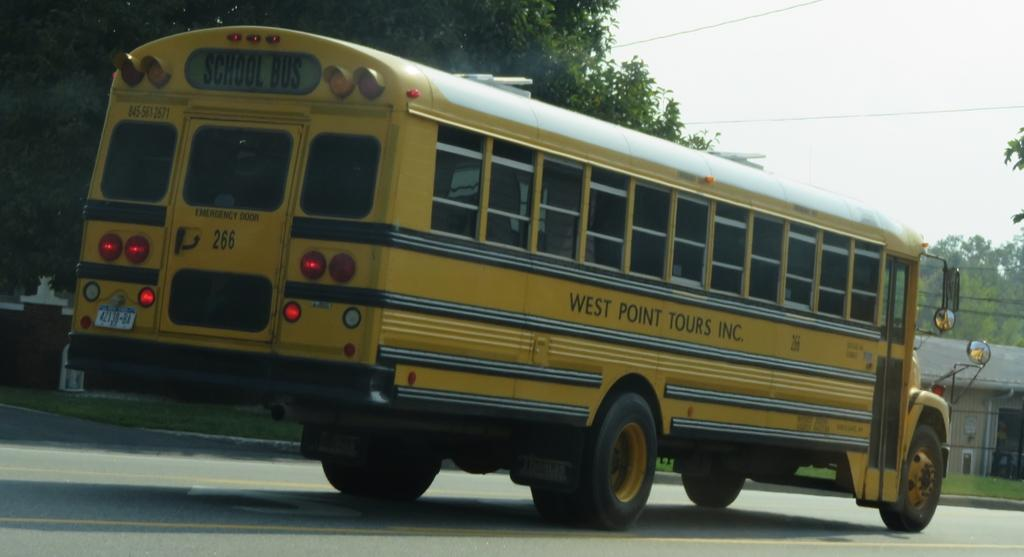What type of vehicle is in the image? There is a yellow bus in the image. What is the bus doing in the image? The bus is moving on the road. What can be seen on the left side of the image? There are trees and a house on the left side of the image. What is visible at the top of the image? The sky is visible at the top of the image. Can you tell me how many people are wearing masks in the image? There are no people wearing masks in the image, as it only features a yellow bus moving on the road. What is the taste of the good-bye in the image? There is no good-bye present in the image, and therefore no taste can be associated with it. 